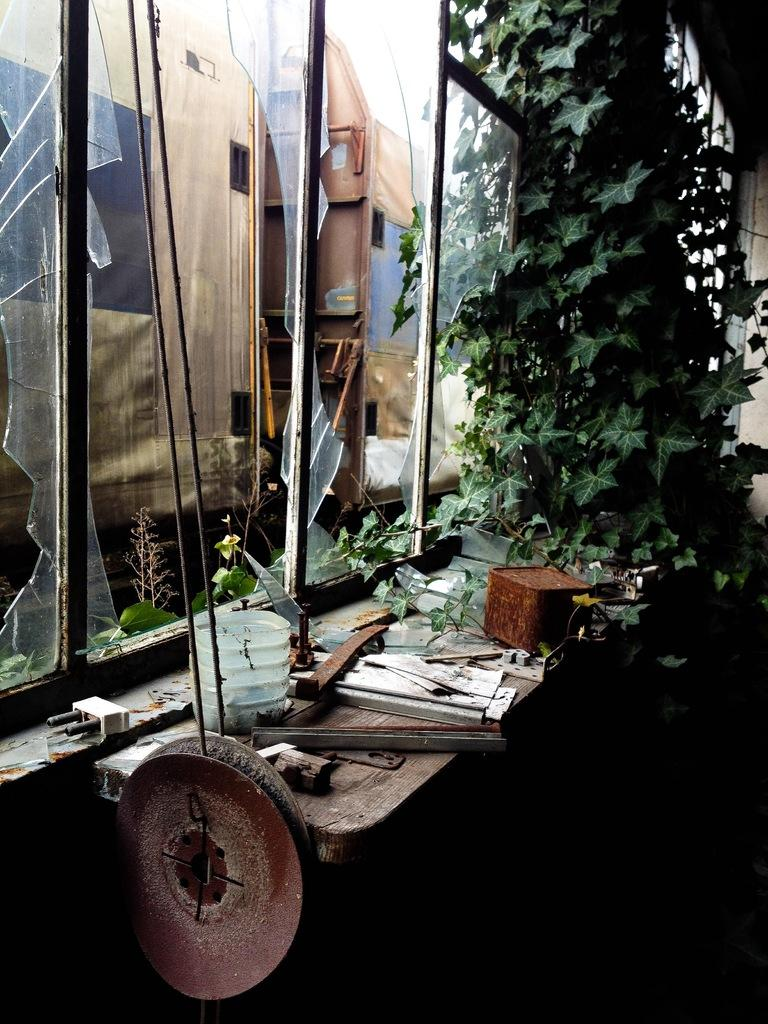What is the condition of the glass window in the image? The glass window in the image is broken. What is located in front of the window? There is a table in front of the window. What is placed above the table? There is a box and a plant above the table, along with other objects. What can be seen through the broken glass window? A building is visible through the glass window. Can you see someone's leg smiling in the image? There is no leg or smiling person present in the image. What type of rice is being cooked in the image? There is no rice or cooking activity depicted in the image. 